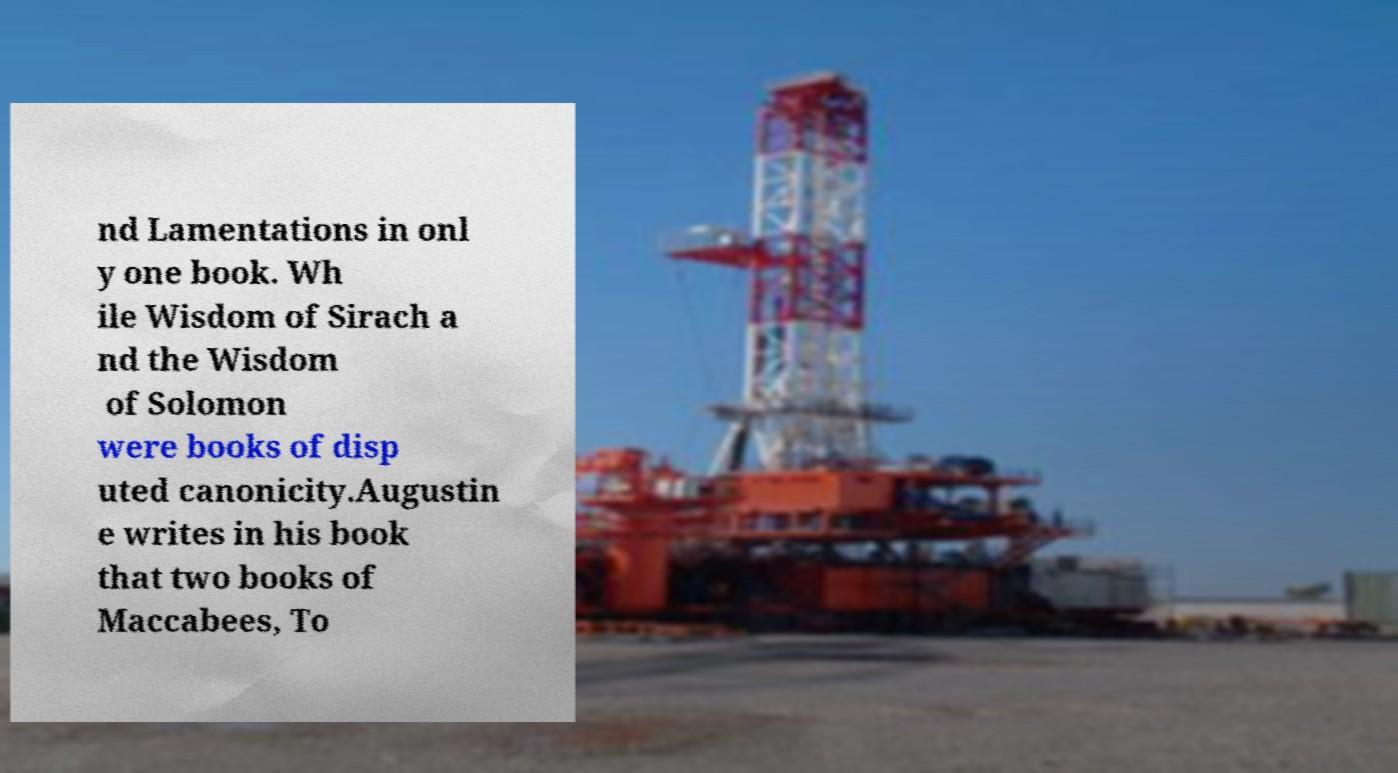Could you extract and type out the text from this image? nd Lamentations in onl y one book. Wh ile Wisdom of Sirach a nd the Wisdom of Solomon were books of disp uted canonicity.Augustin e writes in his book that two books of Maccabees, To 